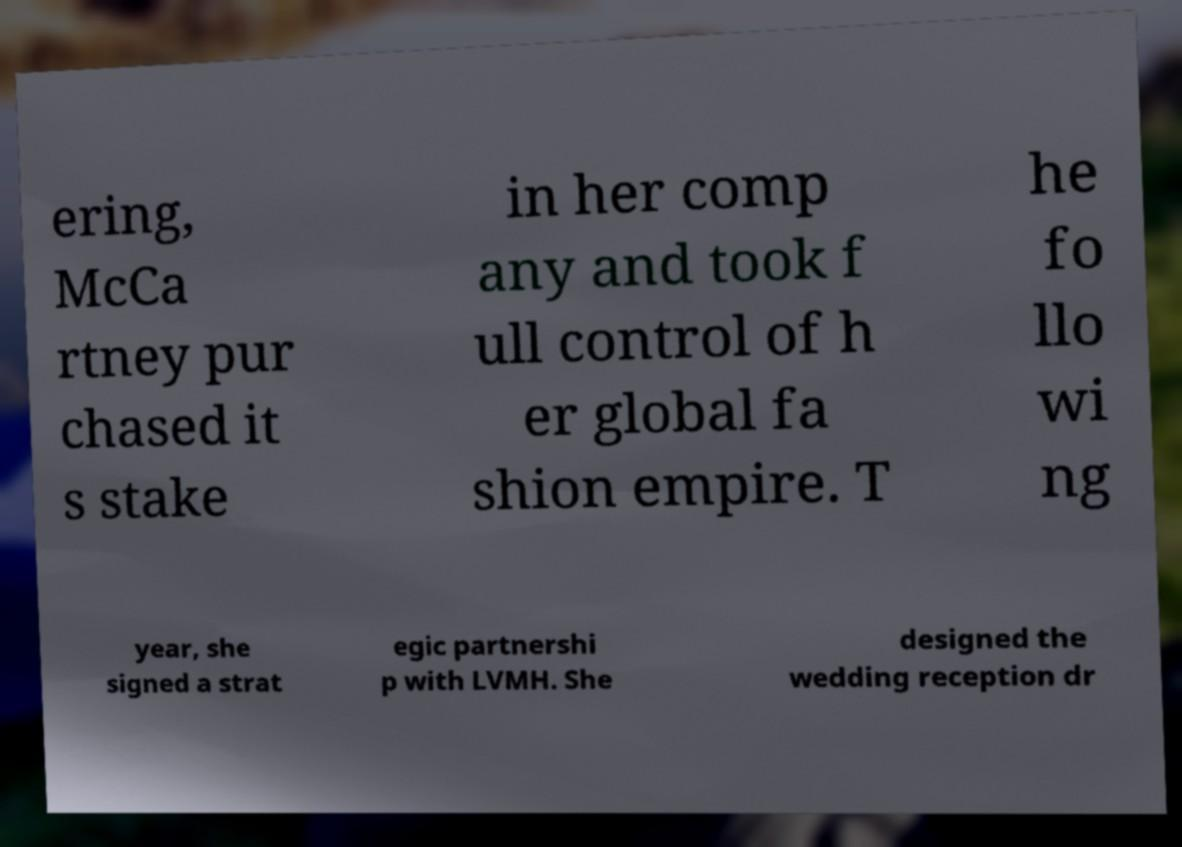For documentation purposes, I need the text within this image transcribed. Could you provide that? ering, McCa rtney pur chased it s stake in her comp any and took f ull control of h er global fa shion empire. T he fo llo wi ng year, she signed a strat egic partnershi p with LVMH. She designed the wedding reception dr 